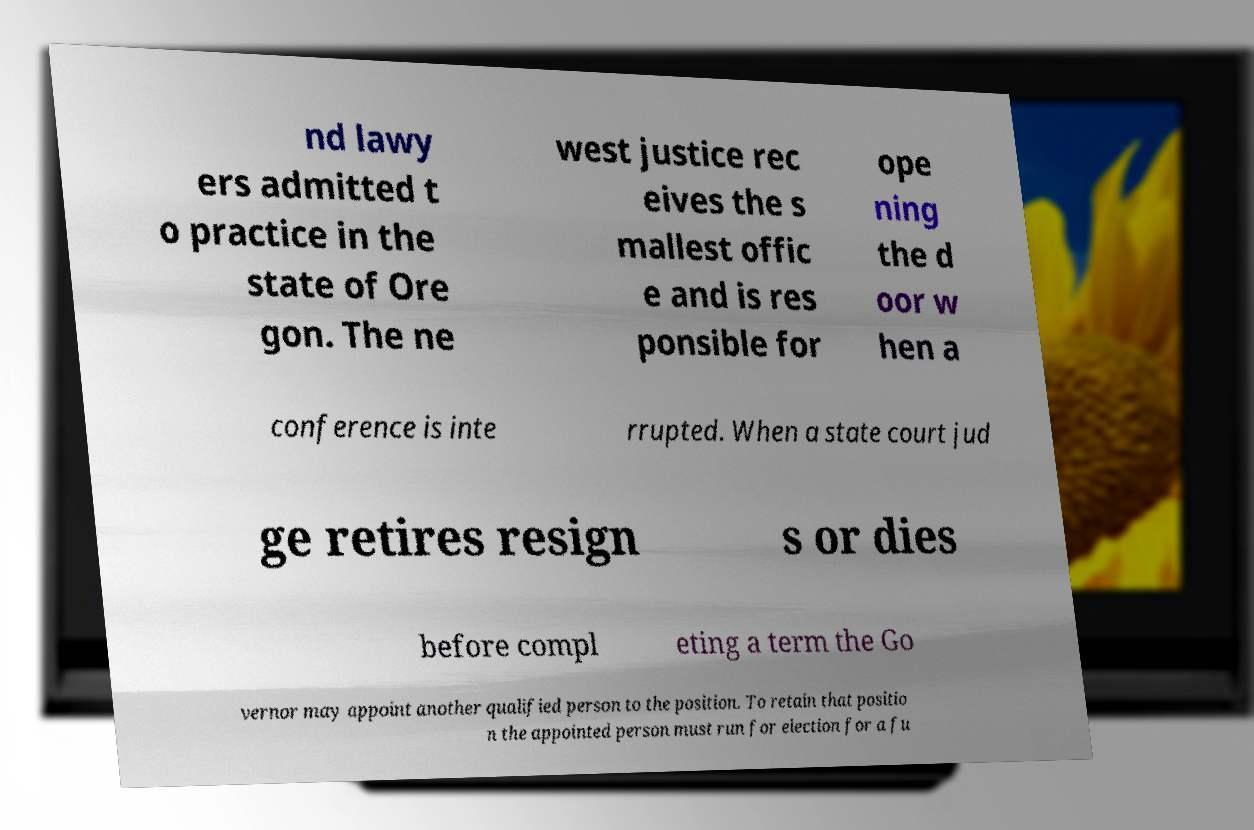Could you assist in decoding the text presented in this image and type it out clearly? nd lawy ers admitted t o practice in the state of Ore gon. The ne west justice rec eives the s mallest offic e and is res ponsible for ope ning the d oor w hen a conference is inte rrupted. When a state court jud ge retires resign s or dies before compl eting a term the Go vernor may appoint another qualified person to the position. To retain that positio n the appointed person must run for election for a fu 